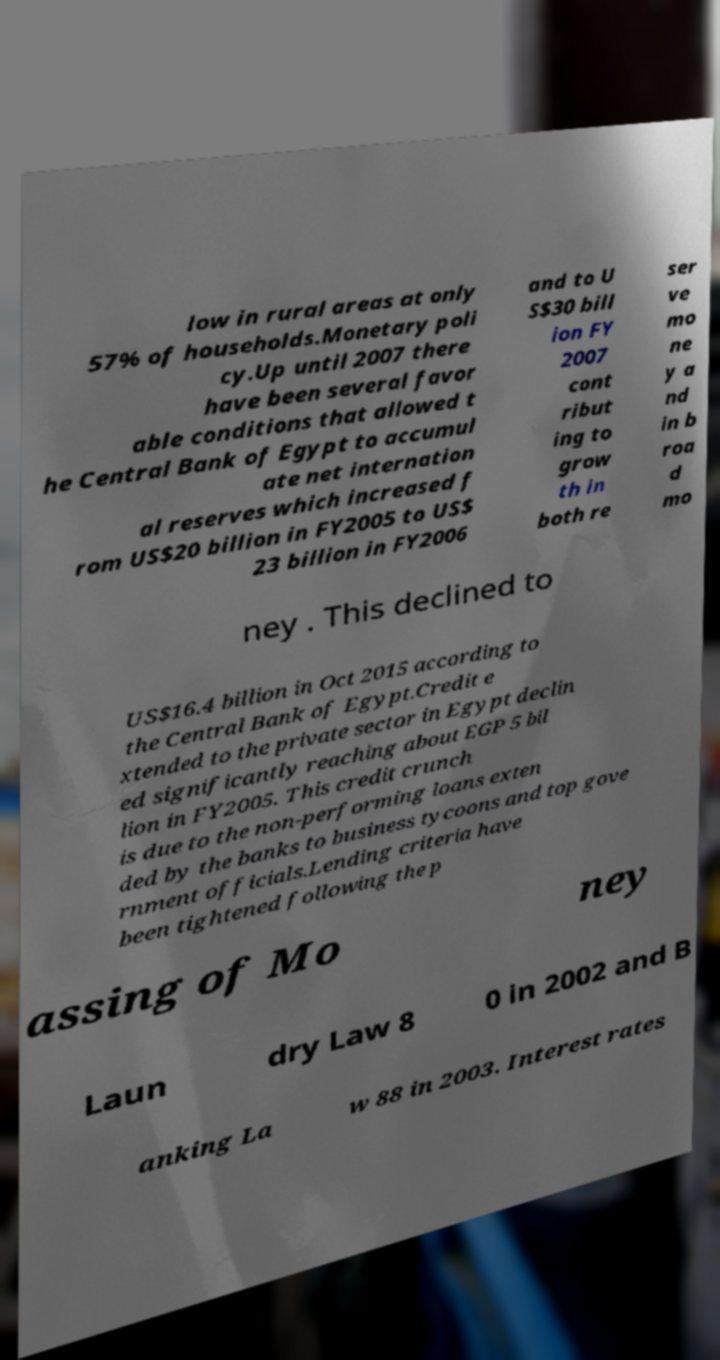Could you extract and type out the text from this image? low in rural areas at only 57% of households.Monetary poli cy.Up until 2007 there have been several favor able conditions that allowed t he Central Bank of Egypt to accumul ate net internation al reserves which increased f rom US$20 billion in FY2005 to US$ 23 billion in FY2006 and to U S$30 bill ion FY 2007 cont ribut ing to grow th in both re ser ve mo ne y a nd in b roa d mo ney . This declined to US$16.4 billion in Oct 2015 according to the Central Bank of Egypt.Credit e xtended to the private sector in Egypt declin ed significantly reaching about EGP 5 bil lion in FY2005. This credit crunch is due to the non-performing loans exten ded by the banks to business tycoons and top gove rnment officials.Lending criteria have been tightened following the p assing of Mo ney Laun dry Law 8 0 in 2002 and B anking La w 88 in 2003. Interest rates 